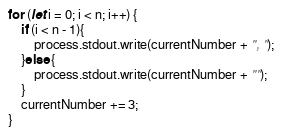Convert code to text. <code><loc_0><loc_0><loc_500><loc_500><_JavaScript_>for (let i = 0; i < n; i++) {
    if (i < n - 1){
        process.stdout.write(currentNumber + ", ");
    }else {
        process.stdout.write(currentNumber + "");
    }
    currentNumber += 3;
}</code> 